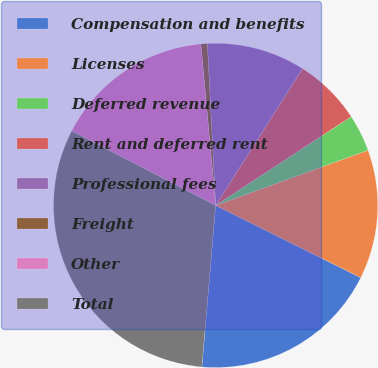Convert chart to OTSL. <chart><loc_0><loc_0><loc_500><loc_500><pie_chart><fcel>Compensation and benefits<fcel>Licenses<fcel>Deferred revenue<fcel>Rent and deferred rent<fcel>Professional fees<fcel>Freight<fcel>Other<fcel>Total<nl><fcel>19.0%<fcel>12.88%<fcel>3.7%<fcel>6.76%<fcel>9.82%<fcel>0.64%<fcel>15.94%<fcel>31.25%<nl></chart> 